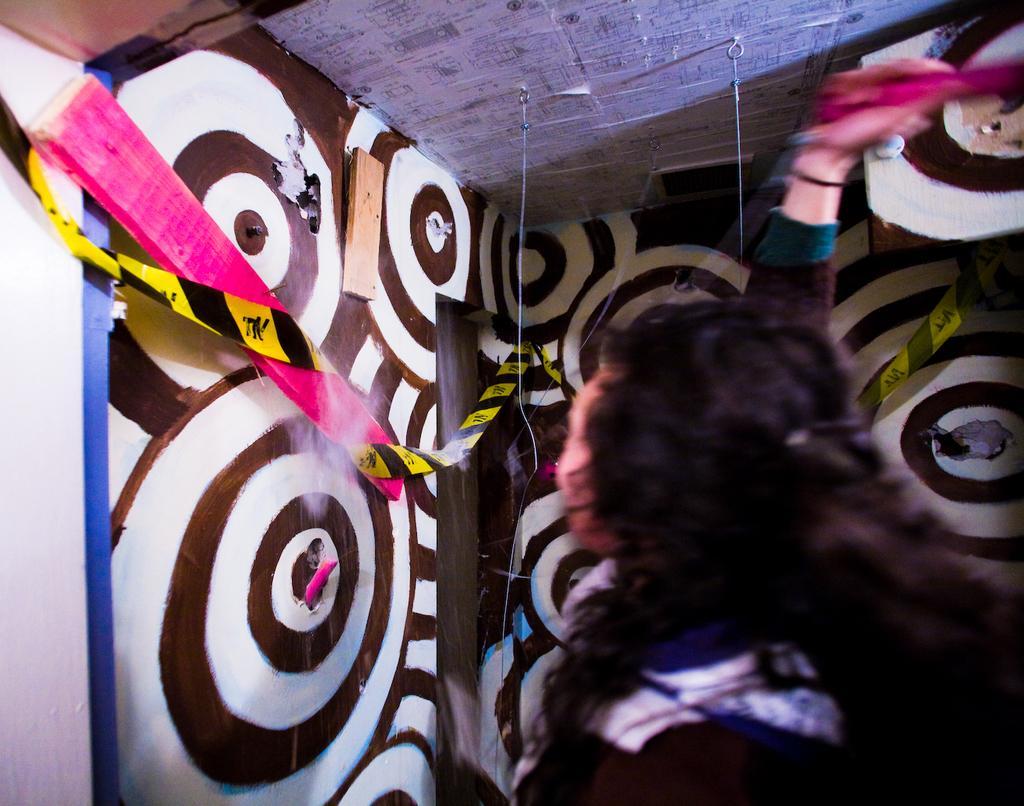How would you summarize this image in a sentence or two? In this image I can see the person with the dress. In-front of the person I can see the wall painting and I can see the wooden objects, black and yellow color object to the wall. I can see the papers attached to the ceiling. 